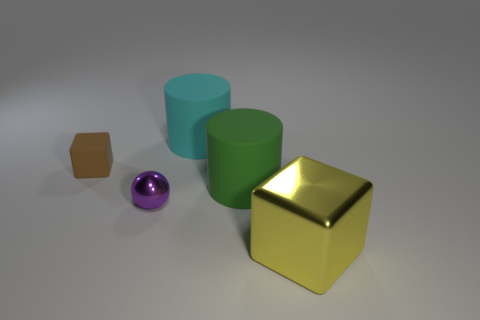Considering the appearance of the objects, could this be a scene from a computer-animated movie or a game? The image has a quality that is reminiscent of computer graphics typically used in animation or video games. The clean edges, perfectly smooth surfaces, and uniform lighting give it a digitally rendered appearance rather than a real-world setting. 